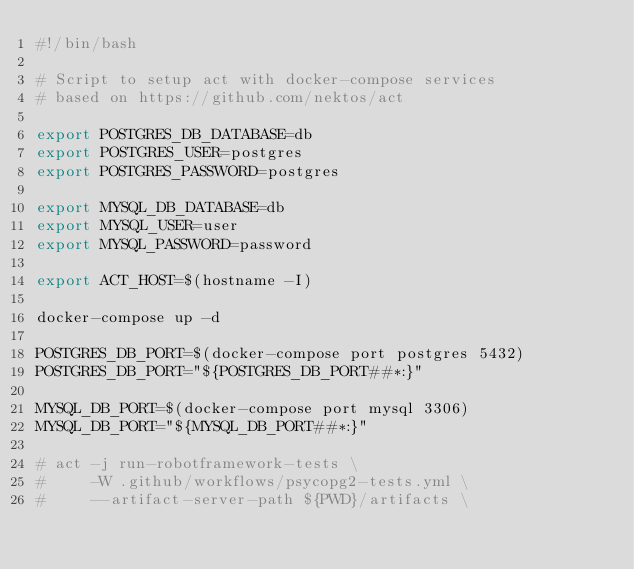<code> <loc_0><loc_0><loc_500><loc_500><_Bash_>#!/bin/bash

# Script to setup act with docker-compose services
# based on https://github.com/nektos/act

export POSTGRES_DB_DATABASE=db
export POSTGRES_USER=postgres
export POSTGRES_PASSWORD=postgres

export MYSQL_DB_DATABASE=db
export MYSQL_USER=user
export MYSQL_PASSWORD=password

export ACT_HOST=$(hostname -I)

docker-compose up -d 

POSTGRES_DB_PORT=$(docker-compose port postgres 5432)
POSTGRES_DB_PORT="${POSTGRES_DB_PORT##*:}"

MYSQL_DB_PORT=$(docker-compose port mysql 3306)
MYSQL_DB_PORT="${MYSQL_DB_PORT##*:}"

# act -j run-robotframework-tests \
#     -W .github/workflows/psycopg2-tests.yml \
#     --artifact-server-path ${PWD}/artifacts \</code> 